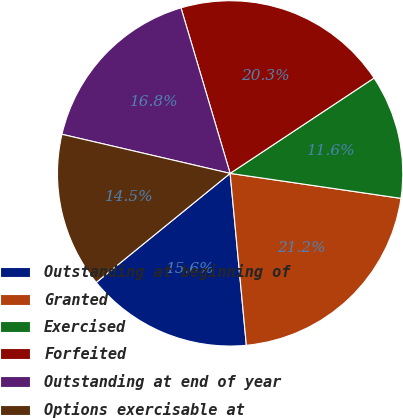<chart> <loc_0><loc_0><loc_500><loc_500><pie_chart><fcel>Outstanding at beginning of<fcel>Granted<fcel>Exercised<fcel>Forfeited<fcel>Outstanding at end of year<fcel>Options exercisable at<nl><fcel>15.62%<fcel>21.19%<fcel>11.62%<fcel>20.28%<fcel>16.77%<fcel>14.51%<nl></chart> 